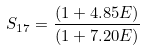Convert formula to latex. <formula><loc_0><loc_0><loc_500><loc_500>S _ { 1 7 } = \frac { ( 1 + 4 . 8 5 E ) } { ( 1 + 7 . 2 0 E ) }</formula> 